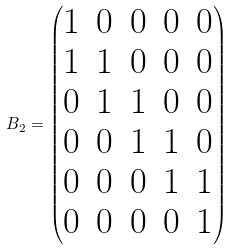Convert formula to latex. <formula><loc_0><loc_0><loc_500><loc_500>B _ { 2 } = \begin{pmatrix} 1 & 0 & 0 & 0 & 0 \\ 1 & 1 & 0 & 0 & 0 \\ 0 & 1 & 1 & 0 & 0 \\ 0 & 0 & 1 & 1 & 0 \\ 0 & 0 & 0 & 1 & 1 \\ 0 & 0 & 0 & 0 & 1 \end{pmatrix}</formula> 